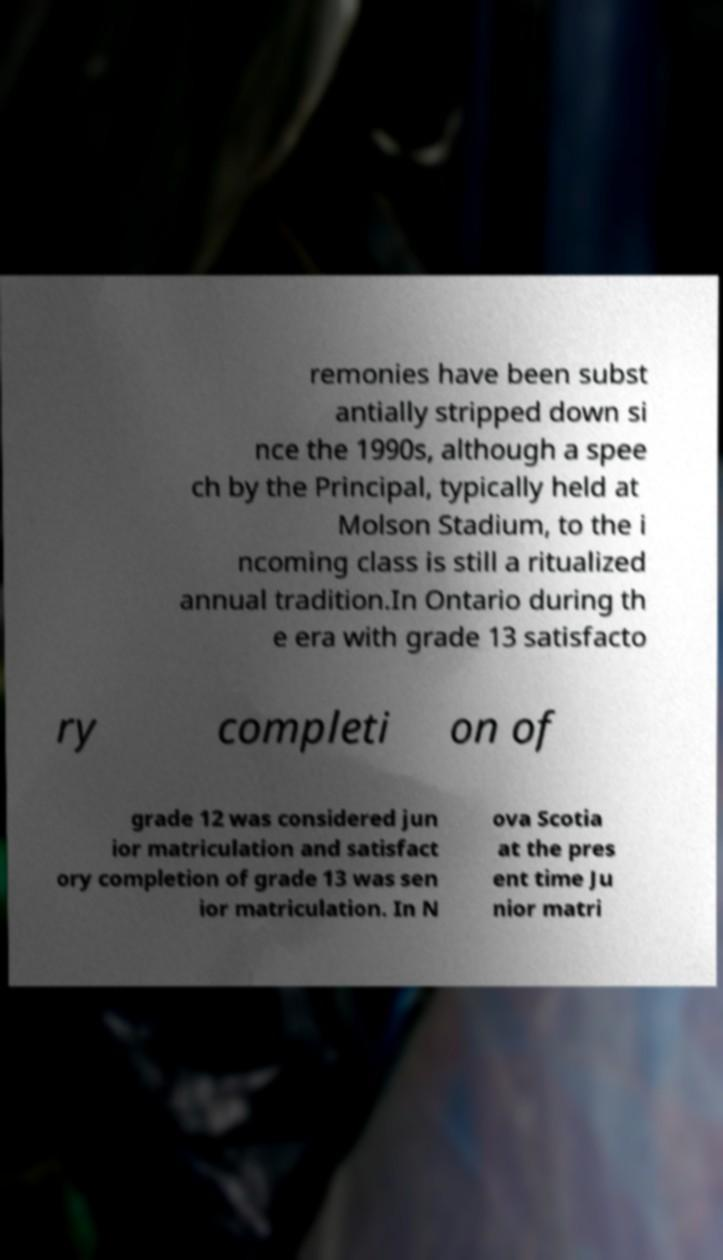Can you accurately transcribe the text from the provided image for me? remonies have been subst antially stripped down si nce the 1990s, although a spee ch by the Principal, typically held at Molson Stadium, to the i ncoming class is still a ritualized annual tradition.In Ontario during th e era with grade 13 satisfacto ry completi on of grade 12 was considered jun ior matriculation and satisfact ory completion of grade 13 was sen ior matriculation. In N ova Scotia at the pres ent time Ju nior matri 